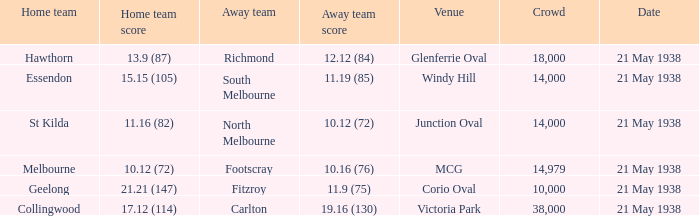Which home team has a site of mcg? Melbourne. 